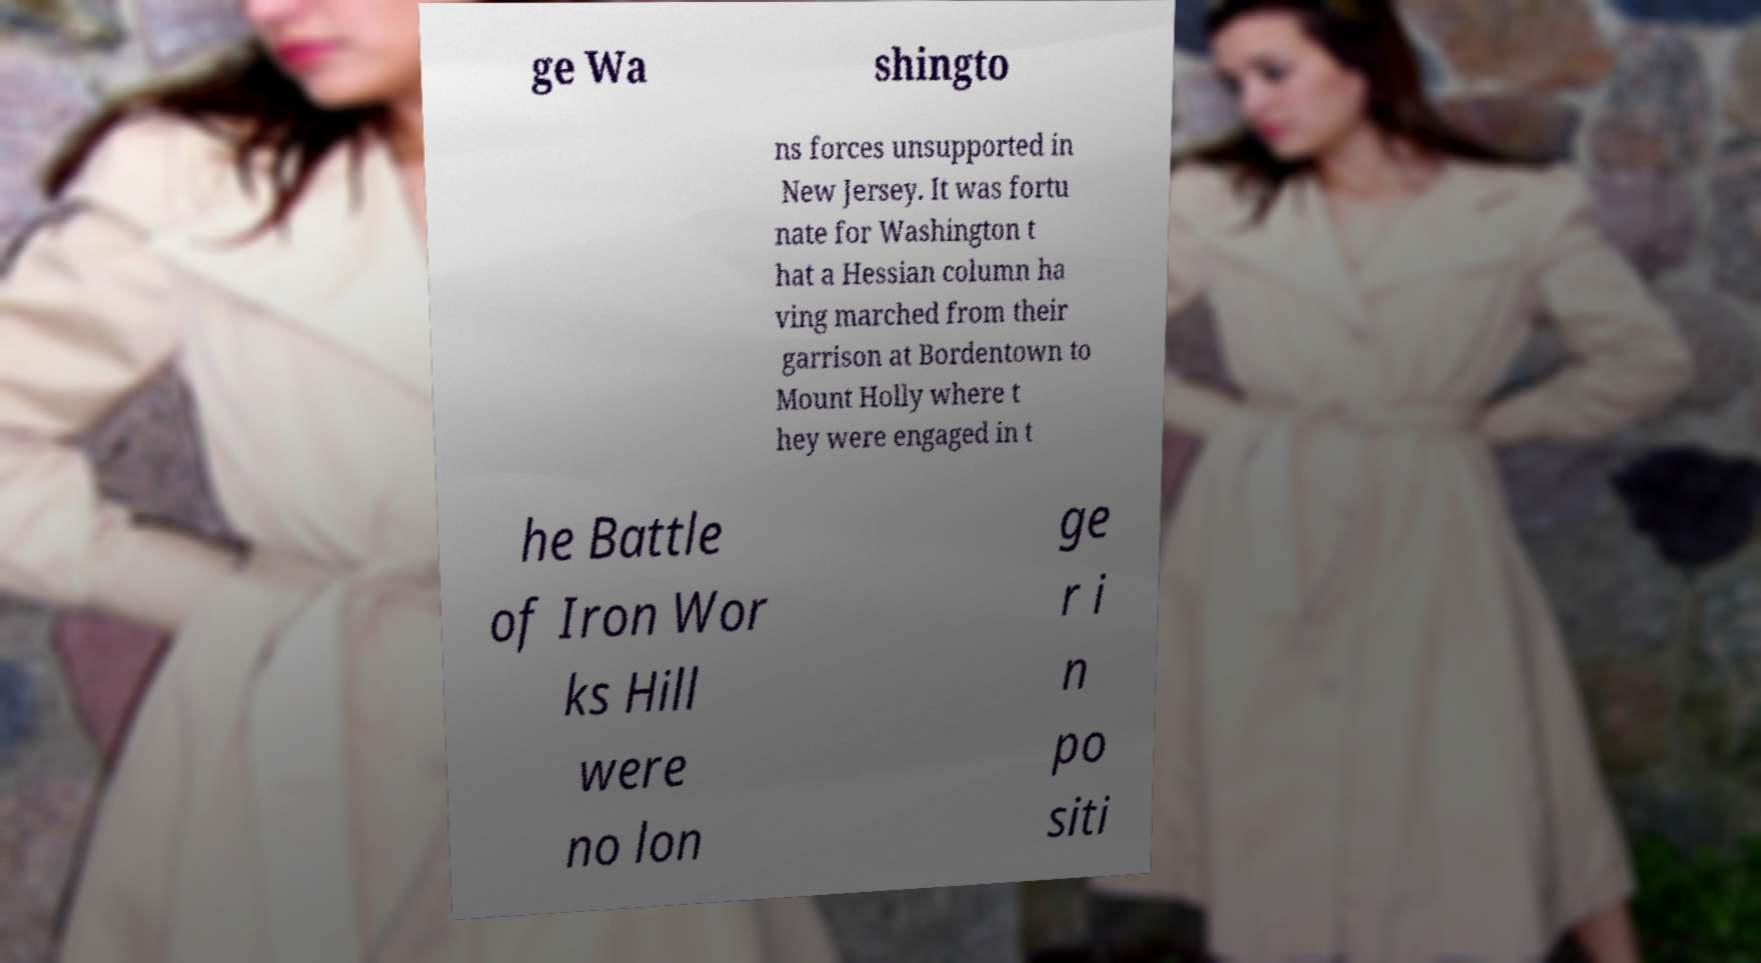What messages or text are displayed in this image? I need them in a readable, typed format. ge Wa shingto ns forces unsupported in New Jersey. It was fortu nate for Washington t hat a Hessian column ha ving marched from their garrison at Bordentown to Mount Holly where t hey were engaged in t he Battle of Iron Wor ks Hill were no lon ge r i n po siti 